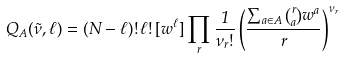Convert formula to latex. <formula><loc_0><loc_0><loc_500><loc_500>Q _ { A } ( \vec { \nu } , \ell ) = ( N - \ell ) ! \, \ell ! \, [ w ^ { \ell } ] \prod _ { r } \frac { 1 } { \nu _ { r } ! } \left ( \frac { \sum _ { a \in A } \binom { r } { a } w ^ { a } } { r } \right ) ^ { \nu _ { r } }</formula> 